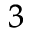Convert formula to latex. <formula><loc_0><loc_0><loc_500><loc_500>_ { 3 }</formula> 